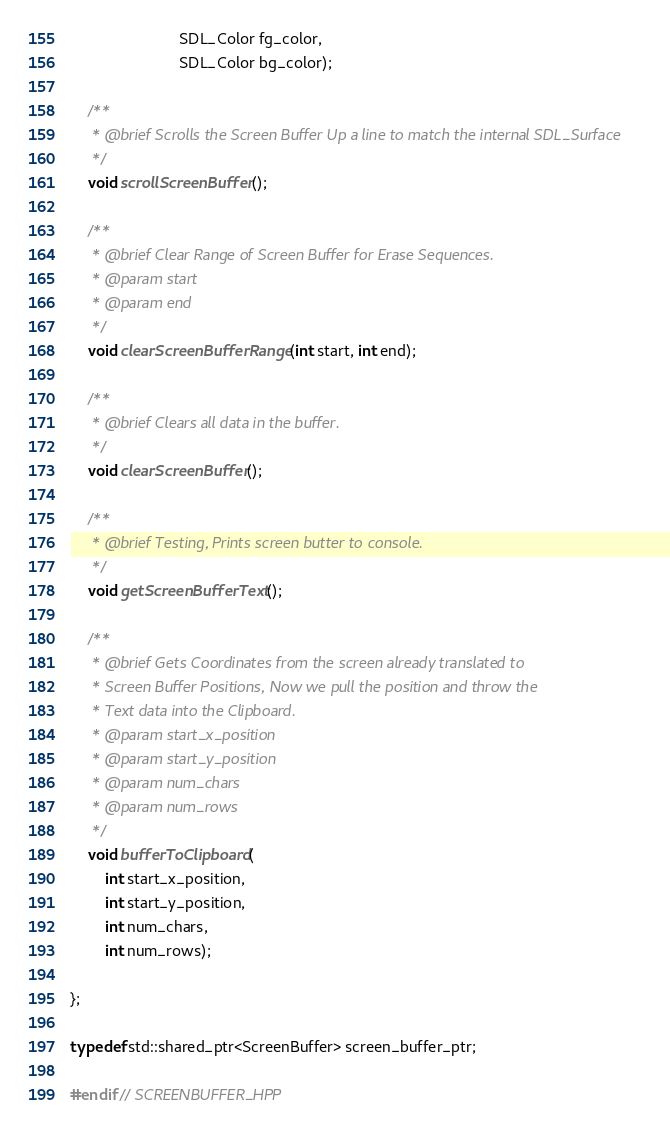<code> <loc_0><loc_0><loc_500><loc_500><_C++_>                         SDL_Color fg_color,
                         SDL_Color bg_color);

    /**
     * @brief Scrolls the Screen Buffer Up a line to match the internal SDL_Surface
     */
    void scrollScreenBuffer();

    /**
     * @brief Clear Range of Screen Buffer for Erase Sequences.
     * @param start
     * @param end
     */
    void clearScreenBufferRange(int start, int end);

    /**
     * @brief Clears all data in the buffer.
     */
    void clearScreenBuffer();

    /**
     * @brief Testing, Prints screen butter to console.
     */
    void getScreenBufferText();

    /**
     * @brief Gets Coordinates from the screen already translated to
     * Screen Buffer Positions, Now we pull the position and throw the
     * Text data into the Clipboard.
     * @param start_x_position
     * @param start_y_position
     * @param num_chars
     * @param num_rows
     */
    void bufferToClipboard(
        int start_x_position,
        int start_y_position,
        int num_chars,
        int num_rows);

};

typedef std::shared_ptr<ScreenBuffer> screen_buffer_ptr;

#endif // SCREENBUFFER_HPP
</code> 